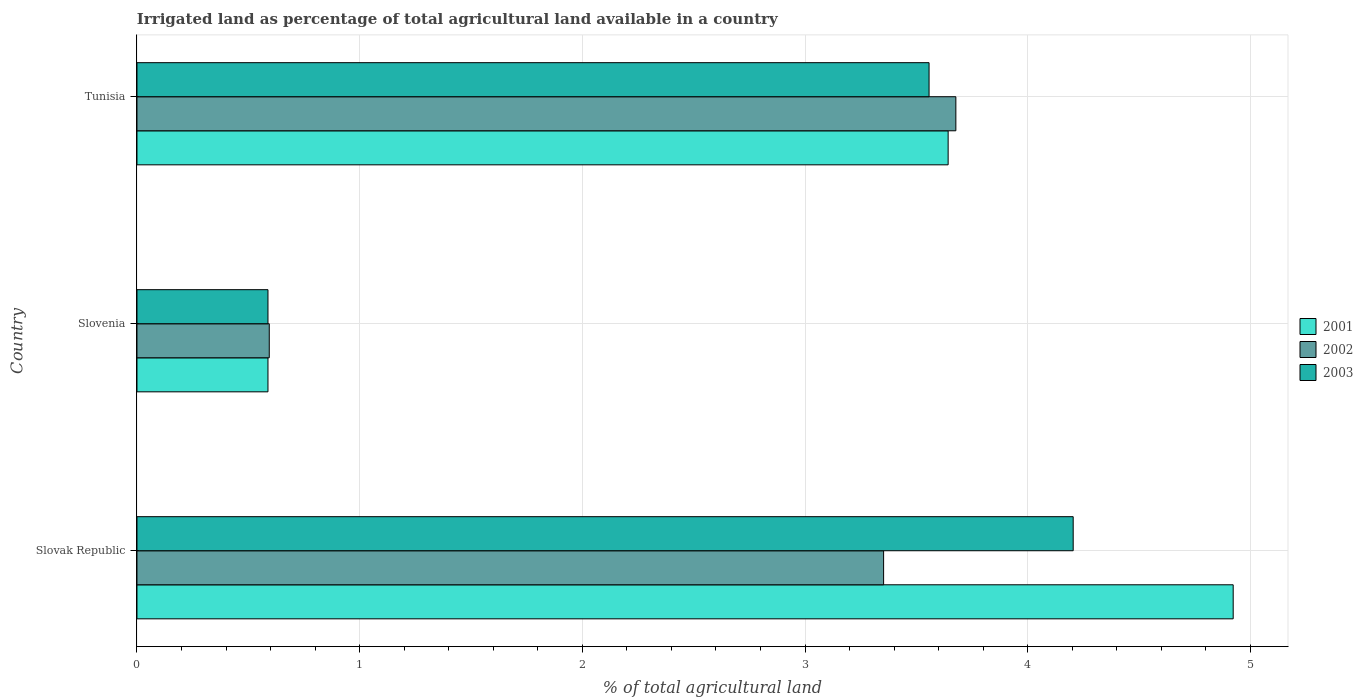How many groups of bars are there?
Make the answer very short. 3. Are the number of bars per tick equal to the number of legend labels?
Give a very brief answer. Yes. What is the label of the 2nd group of bars from the top?
Provide a succinct answer. Slovenia. In how many cases, is the number of bars for a given country not equal to the number of legend labels?
Provide a succinct answer. 0. What is the percentage of irrigated land in 2003 in Slovak Republic?
Make the answer very short. 4.2. Across all countries, what is the maximum percentage of irrigated land in 2001?
Offer a very short reply. 4.92. Across all countries, what is the minimum percentage of irrigated land in 2003?
Your answer should be very brief. 0.59. In which country was the percentage of irrigated land in 2002 maximum?
Offer a very short reply. Tunisia. In which country was the percentage of irrigated land in 2002 minimum?
Keep it short and to the point. Slovenia. What is the total percentage of irrigated land in 2002 in the graph?
Make the answer very short. 7.62. What is the difference between the percentage of irrigated land in 2002 in Slovenia and that in Tunisia?
Offer a very short reply. -3.08. What is the difference between the percentage of irrigated land in 2002 in Tunisia and the percentage of irrigated land in 2003 in Slovenia?
Give a very brief answer. 3.09. What is the average percentage of irrigated land in 2003 per country?
Your response must be concise. 2.78. What is the difference between the percentage of irrigated land in 2001 and percentage of irrigated land in 2003 in Slovenia?
Your response must be concise. 0. What is the ratio of the percentage of irrigated land in 2001 in Slovak Republic to that in Tunisia?
Make the answer very short. 1.35. Is the difference between the percentage of irrigated land in 2001 in Slovak Republic and Slovenia greater than the difference between the percentage of irrigated land in 2003 in Slovak Republic and Slovenia?
Offer a terse response. Yes. What is the difference between the highest and the second highest percentage of irrigated land in 2002?
Provide a succinct answer. 0.32. What is the difference between the highest and the lowest percentage of irrigated land in 2001?
Provide a short and direct response. 4.33. In how many countries, is the percentage of irrigated land in 2001 greater than the average percentage of irrigated land in 2001 taken over all countries?
Ensure brevity in your answer.  2. What does the 1st bar from the bottom in Slovak Republic represents?
Offer a very short reply. 2001. How many countries are there in the graph?
Provide a short and direct response. 3. Are the values on the major ticks of X-axis written in scientific E-notation?
Ensure brevity in your answer.  No. Does the graph contain any zero values?
Your response must be concise. No. Does the graph contain grids?
Provide a short and direct response. Yes. How many legend labels are there?
Give a very brief answer. 3. What is the title of the graph?
Your answer should be very brief. Irrigated land as percentage of total agricultural land available in a country. Does "1971" appear as one of the legend labels in the graph?
Provide a succinct answer. No. What is the label or title of the X-axis?
Keep it short and to the point. % of total agricultural land. What is the label or title of the Y-axis?
Your response must be concise. Country. What is the % of total agricultural land in 2001 in Slovak Republic?
Your response must be concise. 4.92. What is the % of total agricultural land of 2002 in Slovak Republic?
Offer a very short reply. 3.35. What is the % of total agricultural land in 2003 in Slovak Republic?
Ensure brevity in your answer.  4.2. What is the % of total agricultural land of 2001 in Slovenia?
Make the answer very short. 0.59. What is the % of total agricultural land of 2002 in Slovenia?
Offer a very short reply. 0.59. What is the % of total agricultural land in 2003 in Slovenia?
Offer a very short reply. 0.59. What is the % of total agricultural land of 2001 in Tunisia?
Ensure brevity in your answer.  3.64. What is the % of total agricultural land of 2002 in Tunisia?
Make the answer very short. 3.68. What is the % of total agricultural land of 2003 in Tunisia?
Your response must be concise. 3.56. Across all countries, what is the maximum % of total agricultural land of 2001?
Ensure brevity in your answer.  4.92. Across all countries, what is the maximum % of total agricultural land of 2002?
Ensure brevity in your answer.  3.68. Across all countries, what is the maximum % of total agricultural land of 2003?
Your answer should be very brief. 4.2. Across all countries, what is the minimum % of total agricultural land in 2001?
Ensure brevity in your answer.  0.59. Across all countries, what is the minimum % of total agricultural land of 2002?
Your answer should be very brief. 0.59. Across all countries, what is the minimum % of total agricultural land of 2003?
Give a very brief answer. 0.59. What is the total % of total agricultural land in 2001 in the graph?
Keep it short and to the point. 9.15. What is the total % of total agricultural land of 2002 in the graph?
Ensure brevity in your answer.  7.62. What is the total % of total agricultural land of 2003 in the graph?
Make the answer very short. 8.35. What is the difference between the % of total agricultural land of 2001 in Slovak Republic and that in Slovenia?
Make the answer very short. 4.33. What is the difference between the % of total agricultural land in 2002 in Slovak Republic and that in Slovenia?
Offer a very short reply. 2.76. What is the difference between the % of total agricultural land in 2003 in Slovak Republic and that in Slovenia?
Offer a very short reply. 3.62. What is the difference between the % of total agricultural land in 2001 in Slovak Republic and that in Tunisia?
Make the answer very short. 1.28. What is the difference between the % of total agricultural land in 2002 in Slovak Republic and that in Tunisia?
Provide a succinct answer. -0.32. What is the difference between the % of total agricultural land in 2003 in Slovak Republic and that in Tunisia?
Provide a short and direct response. 0.65. What is the difference between the % of total agricultural land of 2001 in Slovenia and that in Tunisia?
Ensure brevity in your answer.  -3.05. What is the difference between the % of total agricultural land in 2002 in Slovenia and that in Tunisia?
Offer a very short reply. -3.08. What is the difference between the % of total agricultural land of 2003 in Slovenia and that in Tunisia?
Keep it short and to the point. -2.97. What is the difference between the % of total agricultural land in 2001 in Slovak Republic and the % of total agricultural land in 2002 in Slovenia?
Provide a short and direct response. 4.33. What is the difference between the % of total agricultural land of 2001 in Slovak Republic and the % of total agricultural land of 2003 in Slovenia?
Provide a succinct answer. 4.33. What is the difference between the % of total agricultural land of 2002 in Slovak Republic and the % of total agricultural land of 2003 in Slovenia?
Ensure brevity in your answer.  2.76. What is the difference between the % of total agricultural land of 2001 in Slovak Republic and the % of total agricultural land of 2002 in Tunisia?
Provide a succinct answer. 1.25. What is the difference between the % of total agricultural land in 2001 in Slovak Republic and the % of total agricultural land in 2003 in Tunisia?
Your response must be concise. 1.37. What is the difference between the % of total agricultural land in 2002 in Slovak Republic and the % of total agricultural land in 2003 in Tunisia?
Offer a very short reply. -0.2. What is the difference between the % of total agricultural land of 2001 in Slovenia and the % of total agricultural land of 2002 in Tunisia?
Your answer should be compact. -3.09. What is the difference between the % of total agricultural land of 2001 in Slovenia and the % of total agricultural land of 2003 in Tunisia?
Your answer should be very brief. -2.97. What is the difference between the % of total agricultural land in 2002 in Slovenia and the % of total agricultural land in 2003 in Tunisia?
Offer a terse response. -2.96. What is the average % of total agricultural land in 2001 per country?
Your answer should be compact. 3.05. What is the average % of total agricultural land in 2002 per country?
Keep it short and to the point. 2.54. What is the average % of total agricultural land of 2003 per country?
Offer a terse response. 2.78. What is the difference between the % of total agricultural land of 2001 and % of total agricultural land of 2002 in Slovak Republic?
Provide a short and direct response. 1.57. What is the difference between the % of total agricultural land in 2001 and % of total agricultural land in 2003 in Slovak Republic?
Your response must be concise. 0.72. What is the difference between the % of total agricultural land in 2002 and % of total agricultural land in 2003 in Slovak Republic?
Provide a short and direct response. -0.85. What is the difference between the % of total agricultural land in 2001 and % of total agricultural land in 2002 in Slovenia?
Keep it short and to the point. -0.01. What is the difference between the % of total agricultural land in 2001 and % of total agricultural land in 2003 in Slovenia?
Make the answer very short. 0. What is the difference between the % of total agricultural land of 2002 and % of total agricultural land of 2003 in Slovenia?
Provide a succinct answer. 0.01. What is the difference between the % of total agricultural land in 2001 and % of total agricultural land in 2002 in Tunisia?
Your answer should be very brief. -0.03. What is the difference between the % of total agricultural land of 2001 and % of total agricultural land of 2003 in Tunisia?
Keep it short and to the point. 0.09. What is the difference between the % of total agricultural land of 2002 and % of total agricultural land of 2003 in Tunisia?
Ensure brevity in your answer.  0.12. What is the ratio of the % of total agricultural land of 2001 in Slovak Republic to that in Slovenia?
Offer a terse response. 8.37. What is the ratio of the % of total agricultural land of 2002 in Slovak Republic to that in Slovenia?
Provide a short and direct response. 5.64. What is the ratio of the % of total agricultural land in 2003 in Slovak Republic to that in Slovenia?
Your answer should be compact. 7.15. What is the ratio of the % of total agricultural land of 2001 in Slovak Republic to that in Tunisia?
Provide a short and direct response. 1.35. What is the ratio of the % of total agricultural land of 2002 in Slovak Republic to that in Tunisia?
Provide a short and direct response. 0.91. What is the ratio of the % of total agricultural land of 2003 in Slovak Republic to that in Tunisia?
Your answer should be compact. 1.18. What is the ratio of the % of total agricultural land in 2001 in Slovenia to that in Tunisia?
Offer a terse response. 0.16. What is the ratio of the % of total agricultural land of 2002 in Slovenia to that in Tunisia?
Offer a terse response. 0.16. What is the ratio of the % of total agricultural land of 2003 in Slovenia to that in Tunisia?
Give a very brief answer. 0.17. What is the difference between the highest and the second highest % of total agricultural land in 2001?
Your answer should be very brief. 1.28. What is the difference between the highest and the second highest % of total agricultural land of 2002?
Ensure brevity in your answer.  0.32. What is the difference between the highest and the second highest % of total agricultural land of 2003?
Your answer should be very brief. 0.65. What is the difference between the highest and the lowest % of total agricultural land in 2001?
Keep it short and to the point. 4.33. What is the difference between the highest and the lowest % of total agricultural land in 2002?
Your answer should be compact. 3.08. What is the difference between the highest and the lowest % of total agricultural land of 2003?
Make the answer very short. 3.62. 